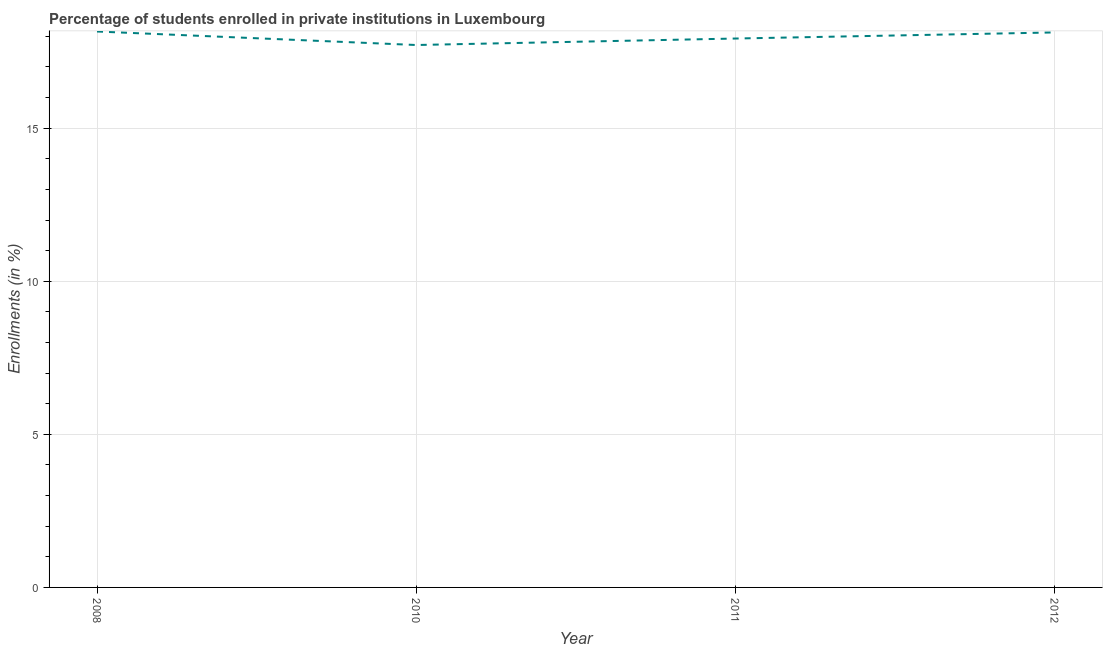What is the enrollments in private institutions in 2008?
Make the answer very short. 18.16. Across all years, what is the maximum enrollments in private institutions?
Keep it short and to the point. 18.16. Across all years, what is the minimum enrollments in private institutions?
Your answer should be compact. 17.72. In which year was the enrollments in private institutions minimum?
Give a very brief answer. 2010. What is the sum of the enrollments in private institutions?
Your answer should be compact. 71.93. What is the difference between the enrollments in private institutions in 2008 and 2012?
Make the answer very short. 0.03. What is the average enrollments in private institutions per year?
Give a very brief answer. 17.98. What is the median enrollments in private institutions?
Offer a very short reply. 18.03. In how many years, is the enrollments in private institutions greater than 11 %?
Provide a succinct answer. 4. What is the ratio of the enrollments in private institutions in 2011 to that in 2012?
Offer a terse response. 0.99. Is the enrollments in private institutions in 2008 less than that in 2011?
Provide a succinct answer. No. Is the difference between the enrollments in private institutions in 2008 and 2012 greater than the difference between any two years?
Make the answer very short. No. What is the difference between the highest and the second highest enrollments in private institutions?
Make the answer very short. 0.03. Is the sum of the enrollments in private institutions in 2008 and 2010 greater than the maximum enrollments in private institutions across all years?
Provide a succinct answer. Yes. What is the difference between the highest and the lowest enrollments in private institutions?
Offer a terse response. 0.44. How many years are there in the graph?
Provide a short and direct response. 4. Are the values on the major ticks of Y-axis written in scientific E-notation?
Your answer should be very brief. No. Does the graph contain grids?
Keep it short and to the point. Yes. What is the title of the graph?
Ensure brevity in your answer.  Percentage of students enrolled in private institutions in Luxembourg. What is the label or title of the X-axis?
Offer a very short reply. Year. What is the label or title of the Y-axis?
Make the answer very short. Enrollments (in %). What is the Enrollments (in %) in 2008?
Provide a succinct answer. 18.16. What is the Enrollments (in %) of 2010?
Your response must be concise. 17.72. What is the Enrollments (in %) in 2011?
Your response must be concise. 17.93. What is the Enrollments (in %) of 2012?
Keep it short and to the point. 18.13. What is the difference between the Enrollments (in %) in 2008 and 2010?
Your answer should be compact. 0.44. What is the difference between the Enrollments (in %) in 2008 and 2011?
Give a very brief answer. 0.23. What is the difference between the Enrollments (in %) in 2008 and 2012?
Offer a very short reply. 0.03. What is the difference between the Enrollments (in %) in 2010 and 2011?
Make the answer very short. -0.21. What is the difference between the Enrollments (in %) in 2010 and 2012?
Offer a very short reply. -0.41. What is the difference between the Enrollments (in %) in 2011 and 2012?
Offer a very short reply. -0.2. What is the ratio of the Enrollments (in %) in 2008 to that in 2011?
Your response must be concise. 1.01. What is the ratio of the Enrollments (in %) in 2008 to that in 2012?
Give a very brief answer. 1. What is the ratio of the Enrollments (in %) in 2010 to that in 2012?
Make the answer very short. 0.98. What is the ratio of the Enrollments (in %) in 2011 to that in 2012?
Offer a very short reply. 0.99. 